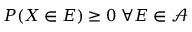<formula> <loc_0><loc_0><loc_500><loc_500>P ( X \in E ) \geq 0 \, \forall E \in { \mathcal { A } }</formula> 